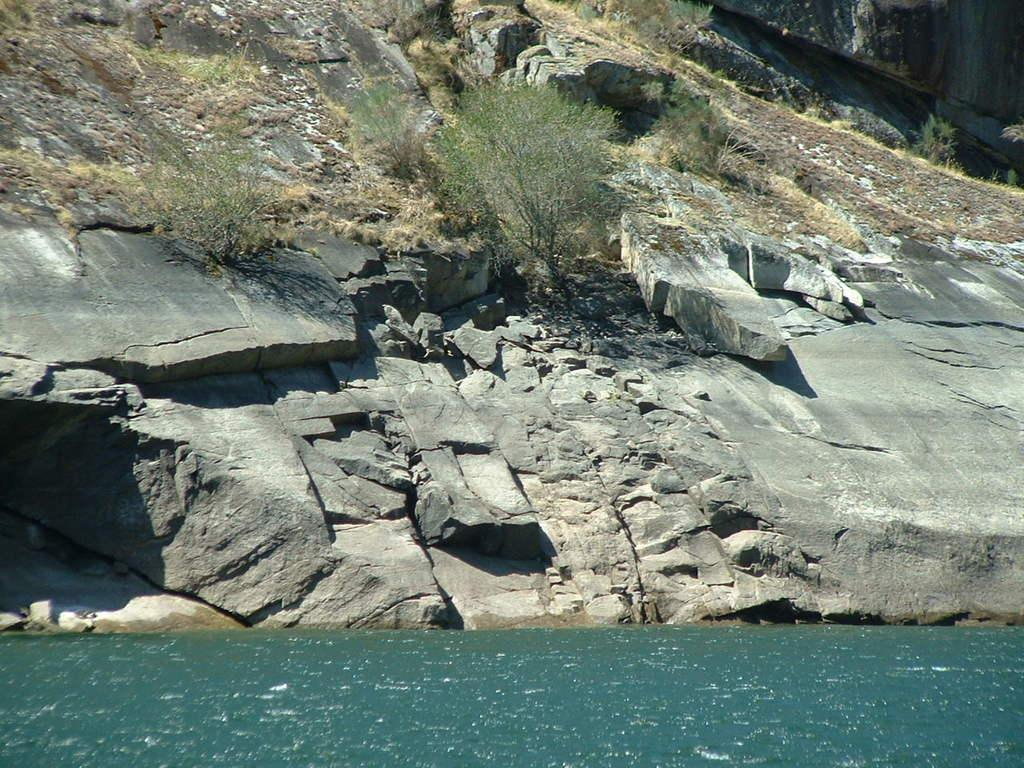What is in the front of the image? There is water in the front of the image. What can be seen in the background of the image? There is grass, stones, and plants in the background of the image. Can you describe the vegetation in the background? The plants in the background are part of the natural landscape. What type of insect can be seen on the shelf in the image? There is no shelf present in the image, and therefore no insect can be seen on it. 